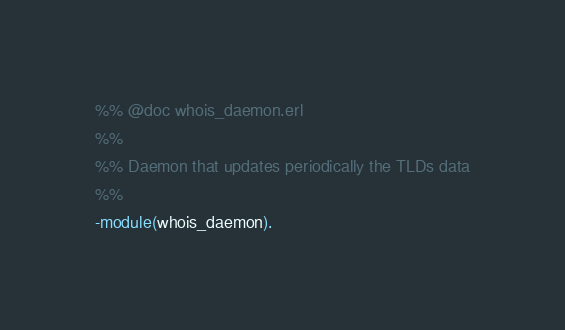Convert code to text. <code><loc_0><loc_0><loc_500><loc_500><_Erlang_>%% @doc whois_daemon.erl
%%
%% Daemon that updates periodically the TLDs data
%%
-module(whois_daemon).
</code> 